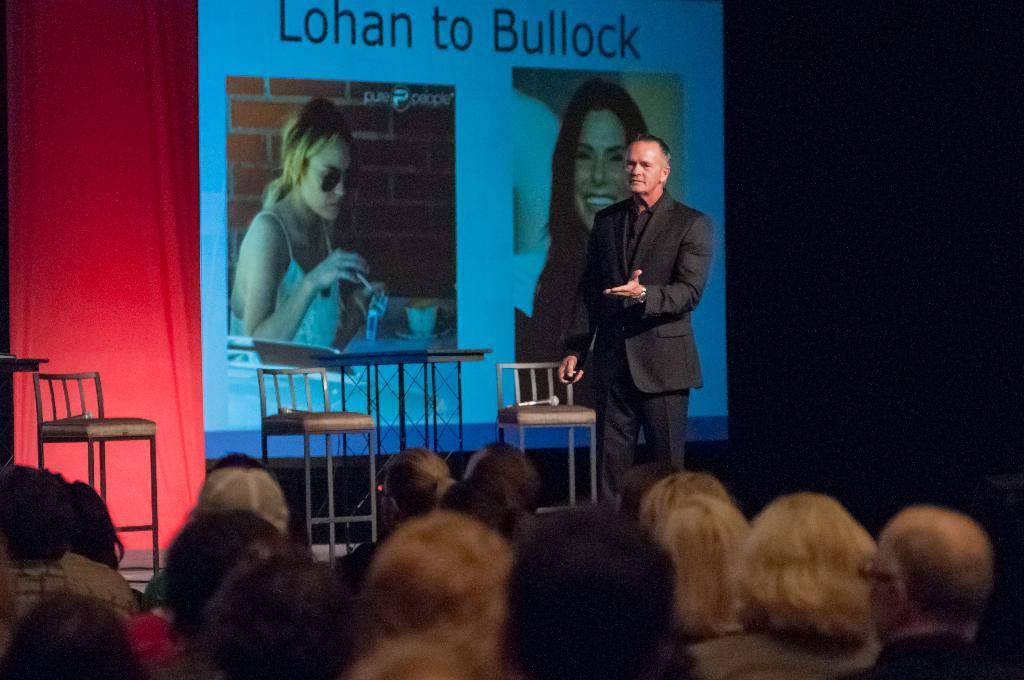How would you summarize this image in a sentence or two? In this image we can see these people are sitting here. This person wearing black blazer is standing on the stage where we can see a three chairs with mics are kept. In the background, we can see the red color cloth, projector screen in which we can see two women and we can see some text. This part of the image is dark. 